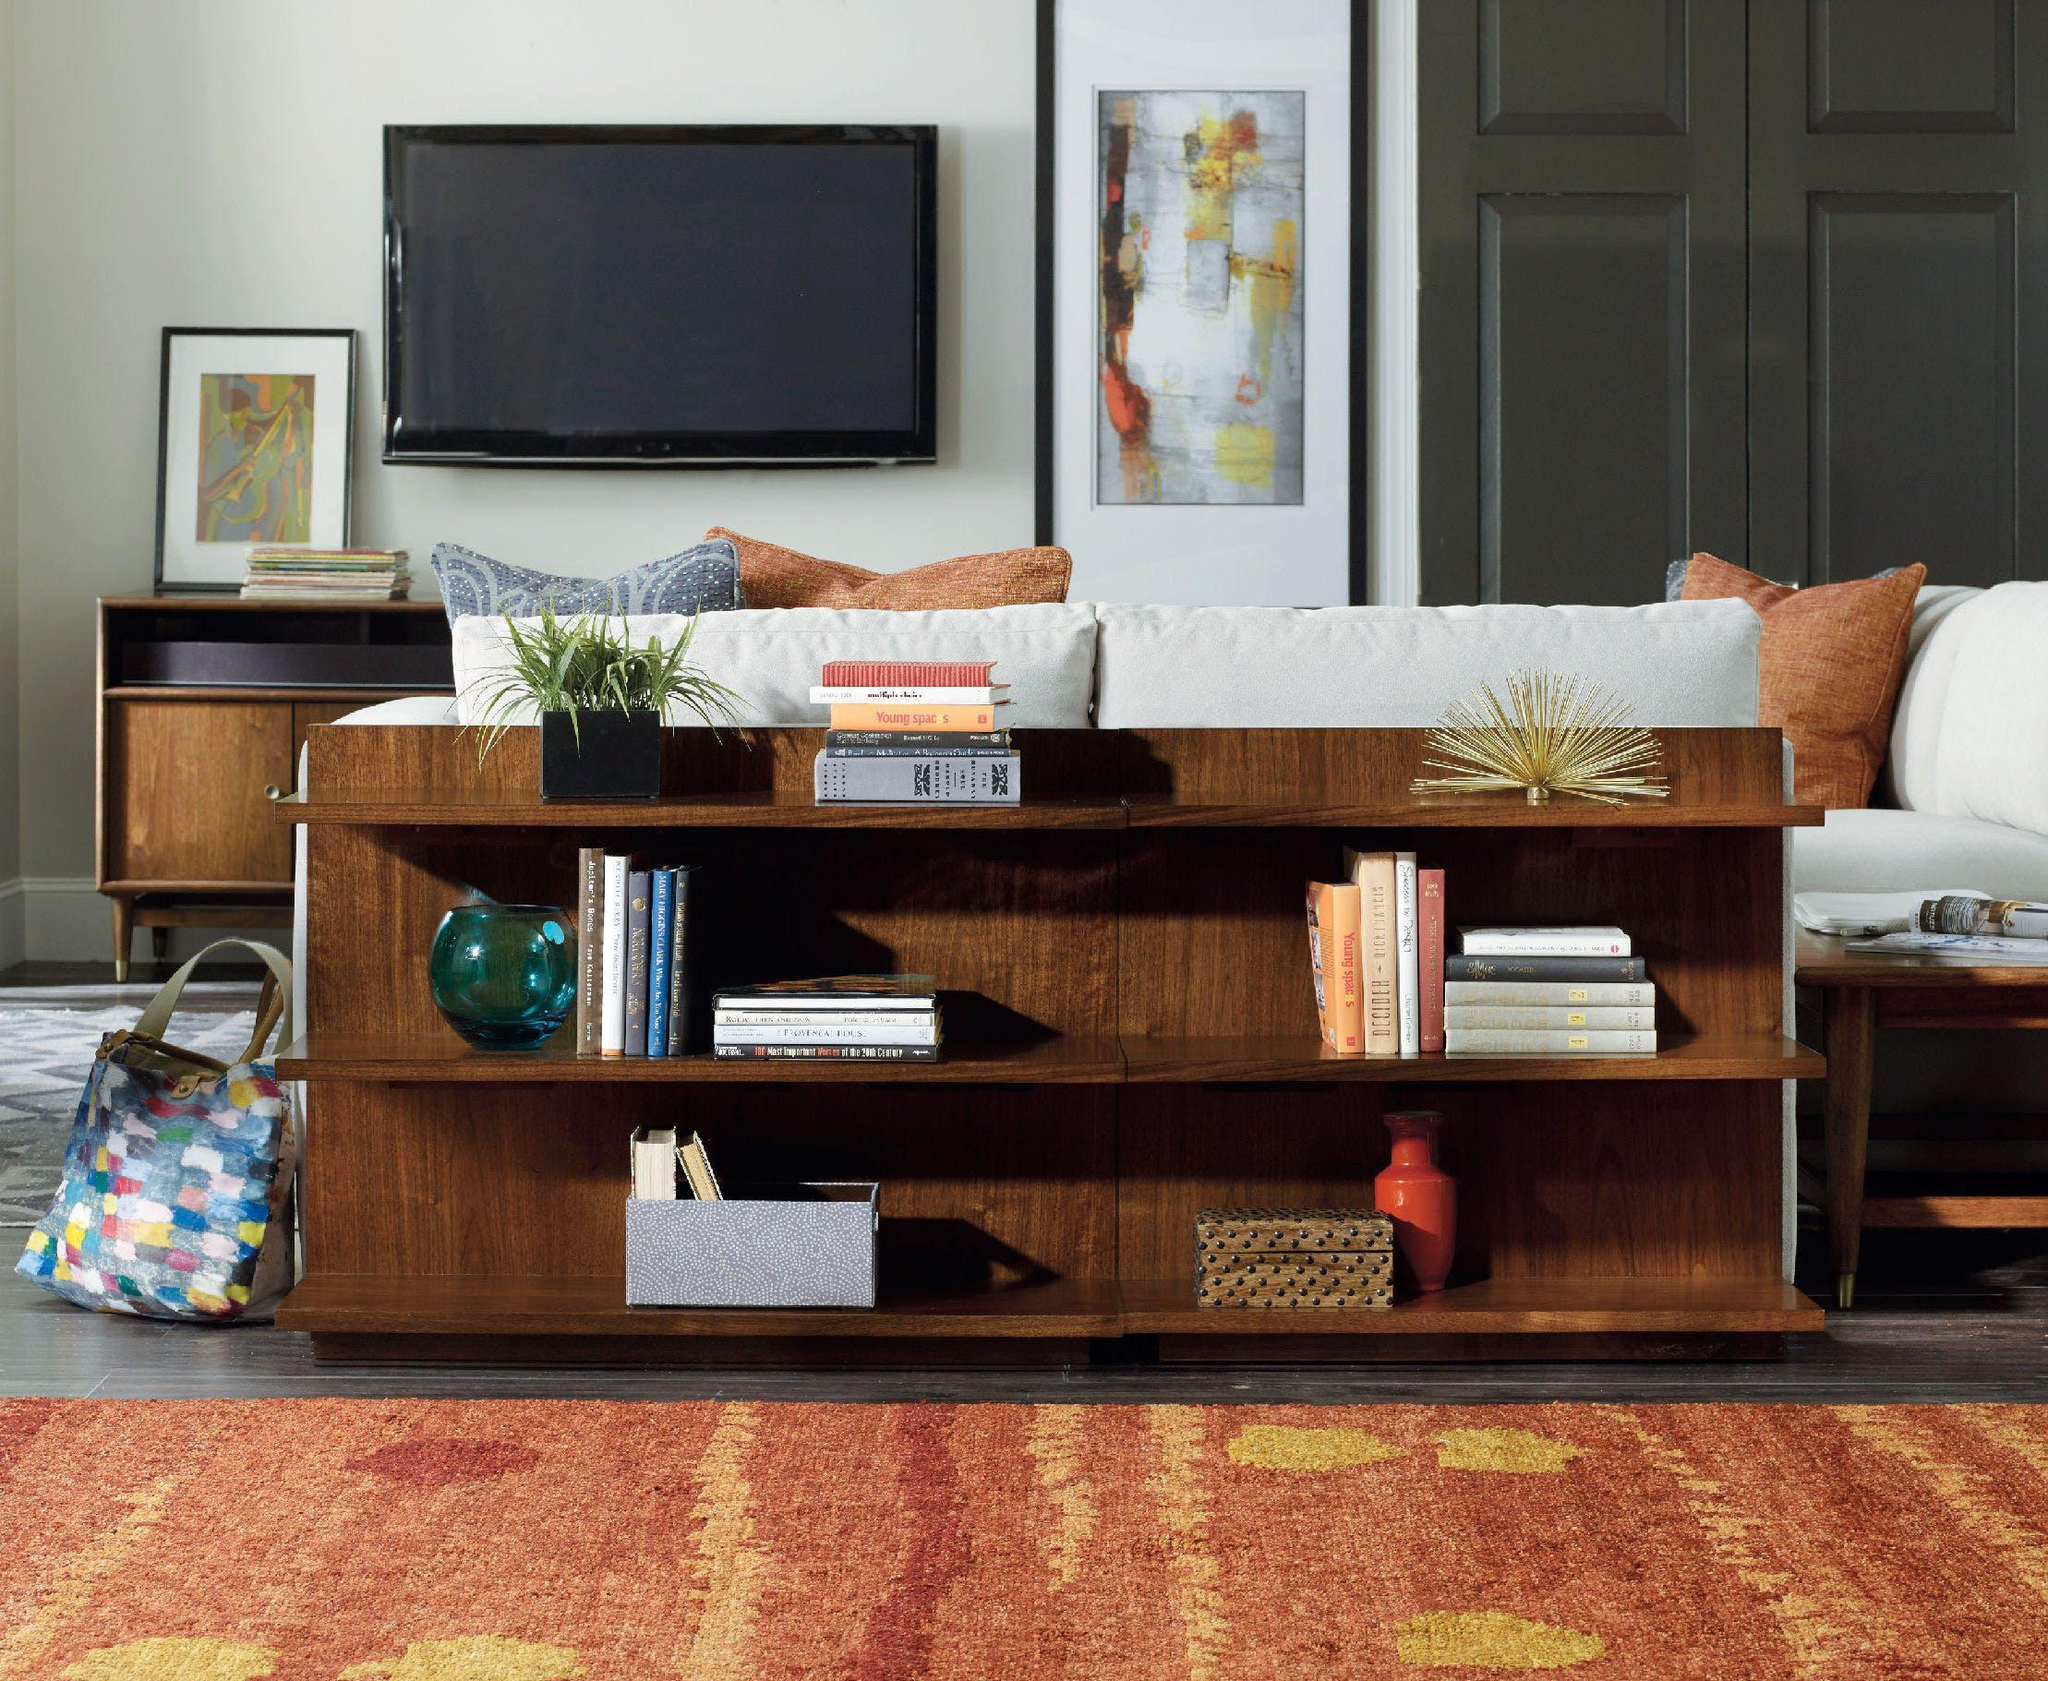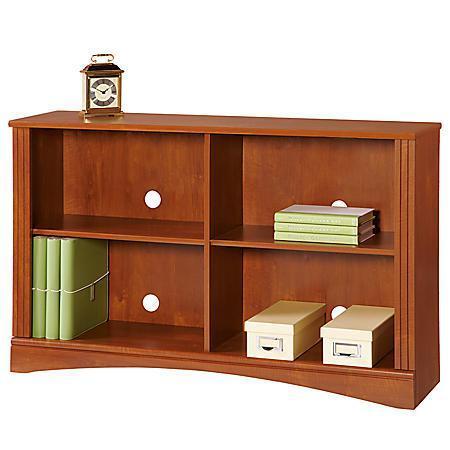The first image is the image on the left, the second image is the image on the right. Given the left and right images, does the statement "There is a stack of three books on the front-most corner of the shelf under the couch in the image on the left." hold true? Answer yes or no. No. The first image is the image on the left, the second image is the image on the right. Given the left and right images, does the statement "there is a book shelf with a sofa and a rug on the floor" hold true? Answer yes or no. Yes. 